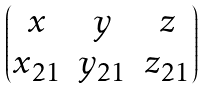Convert formula to latex. <formula><loc_0><loc_0><loc_500><loc_500>\begin{pmatrix} x & y & z \\ x _ { 2 1 } & y _ { 2 1 } & z _ { 2 1 } \end{pmatrix}</formula> 